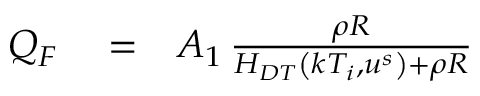<formula> <loc_0><loc_0><loc_500><loc_500>\begin{array} { r l r } { Q _ { F } } & = } & { A _ { 1 } \, \frac { \rho R } { H _ { D T } \left ( k T _ { i } , u ^ { s } \right ) + \rho R } } \end{array}</formula> 